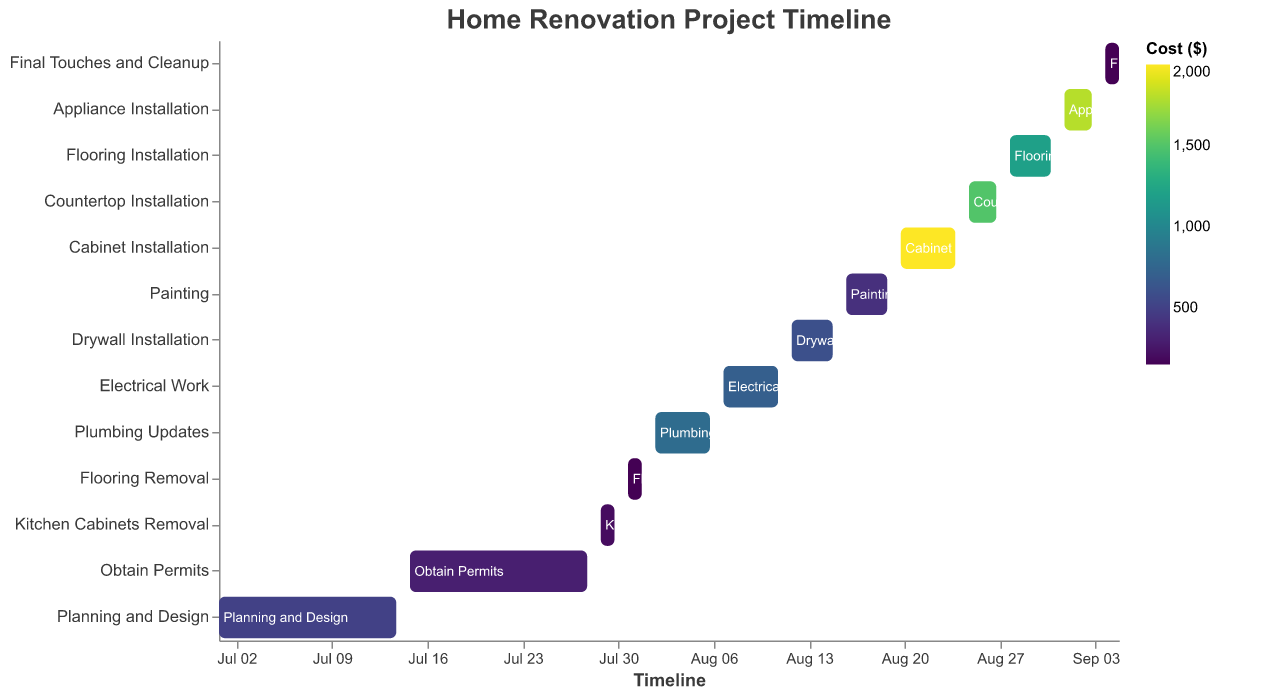What is the title of the Gantt chart? The title is at the top of the figure and is described in the "title" section of the code.
Answer: Home Renovation Project Timeline What are the start and end dates for the Planning and Design task? Locate the Planning and Design task on the y-axis; then, trace the bar to find the start and end dates on the x-axis.
Answer: 2023-07-01 to 2023-07-14 Which task has the highest cost and how much is it? Identify the task with the most intense color since the color intensity represents the cost. Refer to the legend for the exact cost.
Answer: Cabinet Installation, $2000 Between Plumbing Updates and Electrical Work, which one has a longer duration? Check the duration in days for both tasks in the y-axis labels and compare them.
Answer: Both have the same duration, 5 days How many tasks are included in the renovation project? Count the number of tasks listed on the y-axis of the Gantt chart.
Answer: 13 Which task takes the shortest time to complete? Find the task with the smallest bar length on the x-axis, indicating the shortest duration.
Answer: Final Touches and Cleanup, 2 days What is the sum of the costs for Painting and Flooring Installation? Identify the costs of Painting and Flooring Installation from the chart and add them up.
Answer: $400 + $1200 = $1600 How much time does the entire renovation project take, from the very first task to the final task? Locate the start date of the first task and the end date of the last task on the x-axis and calculate the total duration.
Answer: 2023-07-01 to 2023-09-05 Which task(s) overlap in the timeline? Check the x-axis to see if the bars for any tasks occupy the same dates or periods.
Answer: Plumbing Updates and Electrical Work overlap By what date should the Appliances be purchased to ensure they are installed on time? Identify the start date of Appliance Installation from the x-axis.
Answer: By 2023-09-01 